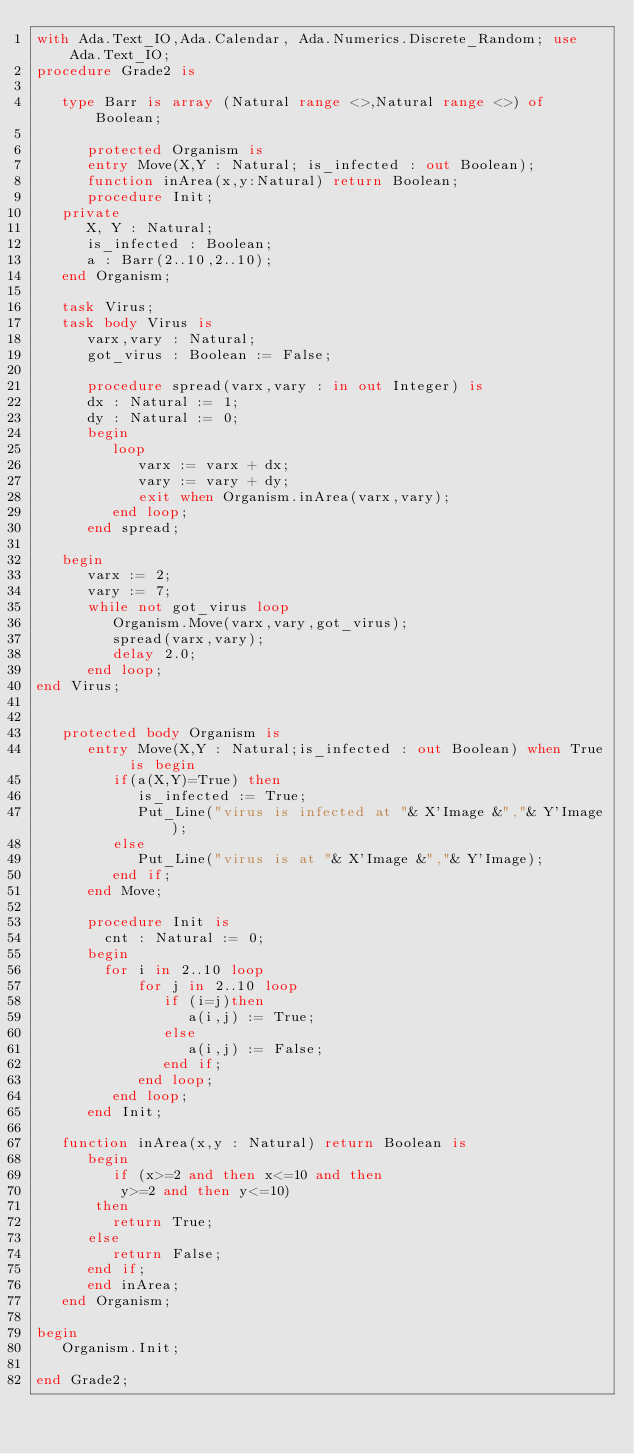<code> <loc_0><loc_0><loc_500><loc_500><_Ada_>with Ada.Text_IO,Ada.Calendar, Ada.Numerics.Discrete_Random; use Ada.Text_IO;
procedure Grade2 is

   type Barr is array (Natural range <>,Natural range <>) of Boolean;

      protected Organism is
      entry Move(X,Y : Natural; is_infected : out Boolean);
      function inArea(x,y:Natural) return Boolean;
      procedure Init;
   private
      X, Y : Natural;
      is_infected : Boolean;
      a : Barr(2..10,2..10);
   end Organism;

   task Virus;
   task body Virus is
      varx,vary : Natural;
      got_virus : Boolean := False;

      procedure spread(varx,vary : in out Integer) is
      dx : Natural := 1;
      dy : Natural := 0;
      begin
         loop
            varx := varx + dx;
            vary := vary + dy;
            exit when Organism.inArea(varx,vary);
         end loop;
      end spread;

   begin
      varx := 2;
      vary := 7;
      while not got_virus loop
         Organism.Move(varx,vary,got_virus);
         spread(varx,vary);
         delay 2.0;
      end loop;
end Virus;


   protected body Organism is
      entry Move(X,Y : Natural;is_infected : out Boolean) when True is begin
         if(a(X,Y)=True) then
            is_infected := True;
            Put_Line("virus is infected at "& X'Image &","& Y'Image);
         else
            Put_Line("virus is at "& X'Image &","& Y'Image);
         end if;
      end Move;

      procedure Init is
        cnt : Natural := 0;
      begin
        for i in 2..10 loop
            for j in 2..10 loop
               if (i=j)then
                  a(i,j) := True;
               else
                  a(i,j) := False;
               end if;
            end loop;
         end loop;
      end Init;

   function inArea(x,y : Natural) return Boolean is
      begin
         if (x>=2 and then x<=10 and then
          y>=2 and then y<=10)
       then
         return True;
      else
         return False;
      end if;
      end inArea;
   end Organism;

begin
   Organism.Init;

end Grade2;
</code> 